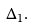<formula> <loc_0><loc_0><loc_500><loc_500>\Delta _ { 1 } .</formula> 